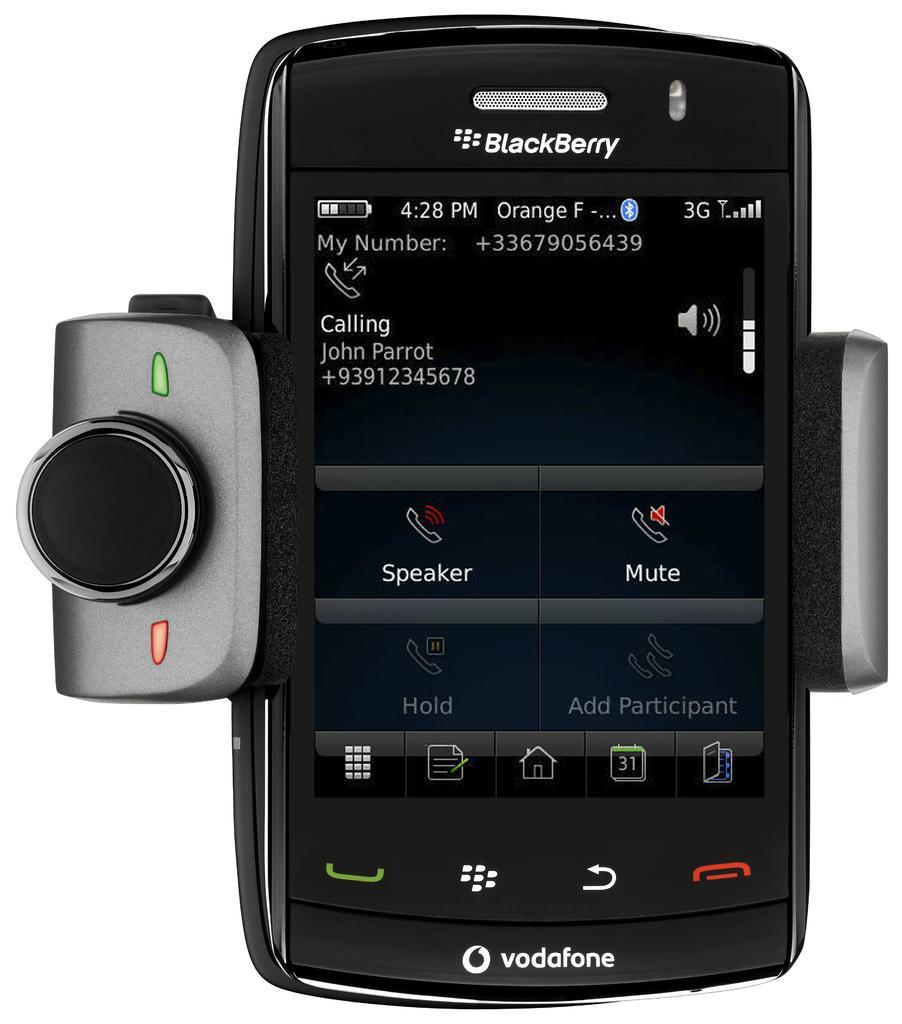Please provide a concise description of this image. In this image there is a cell phone having a lens attached to it. Background is in white color. On the screen there is some text and few icons are visible. 